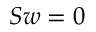Convert formula to latex. <formula><loc_0><loc_0><loc_500><loc_500>S w = 0</formula> 